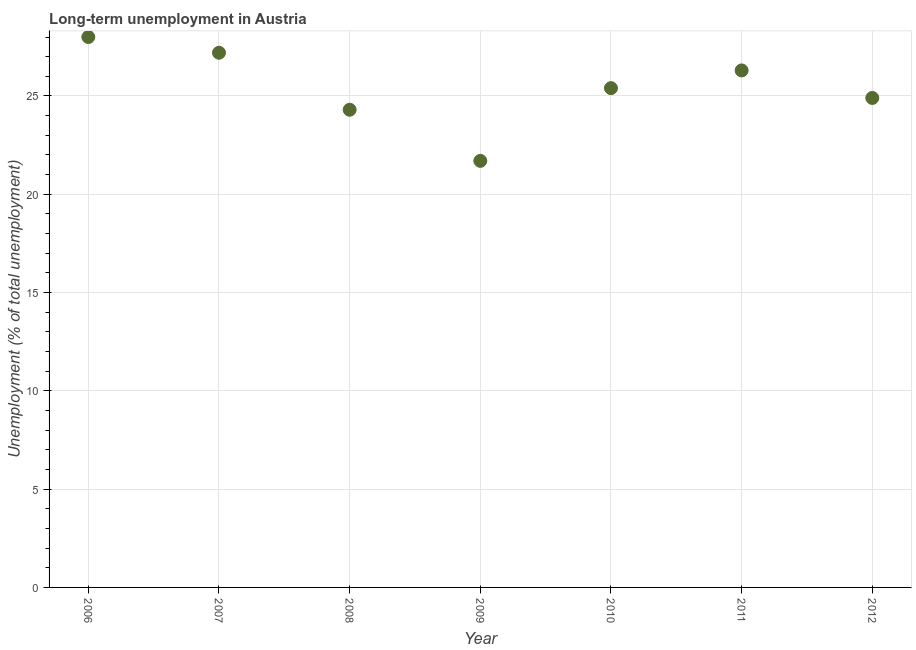What is the long-term unemployment in 2008?
Provide a succinct answer. 24.3. Across all years, what is the minimum long-term unemployment?
Your answer should be very brief. 21.7. What is the sum of the long-term unemployment?
Your response must be concise. 177.8. What is the difference between the long-term unemployment in 2006 and 2011?
Make the answer very short. 1.7. What is the average long-term unemployment per year?
Keep it short and to the point. 25.4. What is the median long-term unemployment?
Offer a terse response. 25.4. In how many years, is the long-term unemployment greater than 9 %?
Keep it short and to the point. 7. What is the ratio of the long-term unemployment in 2007 to that in 2008?
Provide a short and direct response. 1.12. Is the long-term unemployment in 2006 less than that in 2012?
Make the answer very short. No. What is the difference between the highest and the second highest long-term unemployment?
Your answer should be compact. 0.8. Is the sum of the long-term unemployment in 2008 and 2009 greater than the maximum long-term unemployment across all years?
Make the answer very short. Yes. What is the difference between the highest and the lowest long-term unemployment?
Ensure brevity in your answer.  6.3. In how many years, is the long-term unemployment greater than the average long-term unemployment taken over all years?
Offer a terse response. 3. How many dotlines are there?
Your answer should be very brief. 1. How many years are there in the graph?
Your answer should be compact. 7. Are the values on the major ticks of Y-axis written in scientific E-notation?
Ensure brevity in your answer.  No. Does the graph contain grids?
Offer a very short reply. Yes. What is the title of the graph?
Provide a short and direct response. Long-term unemployment in Austria. What is the label or title of the Y-axis?
Provide a short and direct response. Unemployment (% of total unemployment). What is the Unemployment (% of total unemployment) in 2006?
Give a very brief answer. 28. What is the Unemployment (% of total unemployment) in 2007?
Ensure brevity in your answer.  27.2. What is the Unemployment (% of total unemployment) in 2008?
Offer a terse response. 24.3. What is the Unemployment (% of total unemployment) in 2009?
Ensure brevity in your answer.  21.7. What is the Unemployment (% of total unemployment) in 2010?
Your answer should be compact. 25.4. What is the Unemployment (% of total unemployment) in 2011?
Keep it short and to the point. 26.3. What is the Unemployment (% of total unemployment) in 2012?
Make the answer very short. 24.9. What is the difference between the Unemployment (% of total unemployment) in 2006 and 2010?
Offer a terse response. 2.6. What is the difference between the Unemployment (% of total unemployment) in 2006 and 2012?
Your answer should be compact. 3.1. What is the difference between the Unemployment (% of total unemployment) in 2007 and 2008?
Ensure brevity in your answer.  2.9. What is the difference between the Unemployment (% of total unemployment) in 2007 and 2011?
Give a very brief answer. 0.9. What is the difference between the Unemployment (% of total unemployment) in 2009 and 2010?
Your response must be concise. -3.7. What is the difference between the Unemployment (% of total unemployment) in 2009 and 2011?
Your response must be concise. -4.6. What is the difference between the Unemployment (% of total unemployment) in 2010 and 2012?
Offer a terse response. 0.5. What is the difference between the Unemployment (% of total unemployment) in 2011 and 2012?
Your response must be concise. 1.4. What is the ratio of the Unemployment (% of total unemployment) in 2006 to that in 2008?
Keep it short and to the point. 1.15. What is the ratio of the Unemployment (% of total unemployment) in 2006 to that in 2009?
Ensure brevity in your answer.  1.29. What is the ratio of the Unemployment (% of total unemployment) in 2006 to that in 2010?
Your answer should be very brief. 1.1. What is the ratio of the Unemployment (% of total unemployment) in 2006 to that in 2011?
Offer a very short reply. 1.06. What is the ratio of the Unemployment (% of total unemployment) in 2006 to that in 2012?
Your answer should be very brief. 1.12. What is the ratio of the Unemployment (% of total unemployment) in 2007 to that in 2008?
Make the answer very short. 1.12. What is the ratio of the Unemployment (% of total unemployment) in 2007 to that in 2009?
Make the answer very short. 1.25. What is the ratio of the Unemployment (% of total unemployment) in 2007 to that in 2010?
Provide a short and direct response. 1.07. What is the ratio of the Unemployment (% of total unemployment) in 2007 to that in 2011?
Provide a short and direct response. 1.03. What is the ratio of the Unemployment (% of total unemployment) in 2007 to that in 2012?
Your response must be concise. 1.09. What is the ratio of the Unemployment (% of total unemployment) in 2008 to that in 2009?
Your answer should be very brief. 1.12. What is the ratio of the Unemployment (% of total unemployment) in 2008 to that in 2010?
Ensure brevity in your answer.  0.96. What is the ratio of the Unemployment (% of total unemployment) in 2008 to that in 2011?
Give a very brief answer. 0.92. What is the ratio of the Unemployment (% of total unemployment) in 2008 to that in 2012?
Offer a very short reply. 0.98. What is the ratio of the Unemployment (% of total unemployment) in 2009 to that in 2010?
Offer a terse response. 0.85. What is the ratio of the Unemployment (% of total unemployment) in 2009 to that in 2011?
Keep it short and to the point. 0.82. What is the ratio of the Unemployment (% of total unemployment) in 2009 to that in 2012?
Your answer should be compact. 0.87. What is the ratio of the Unemployment (% of total unemployment) in 2011 to that in 2012?
Provide a succinct answer. 1.06. 